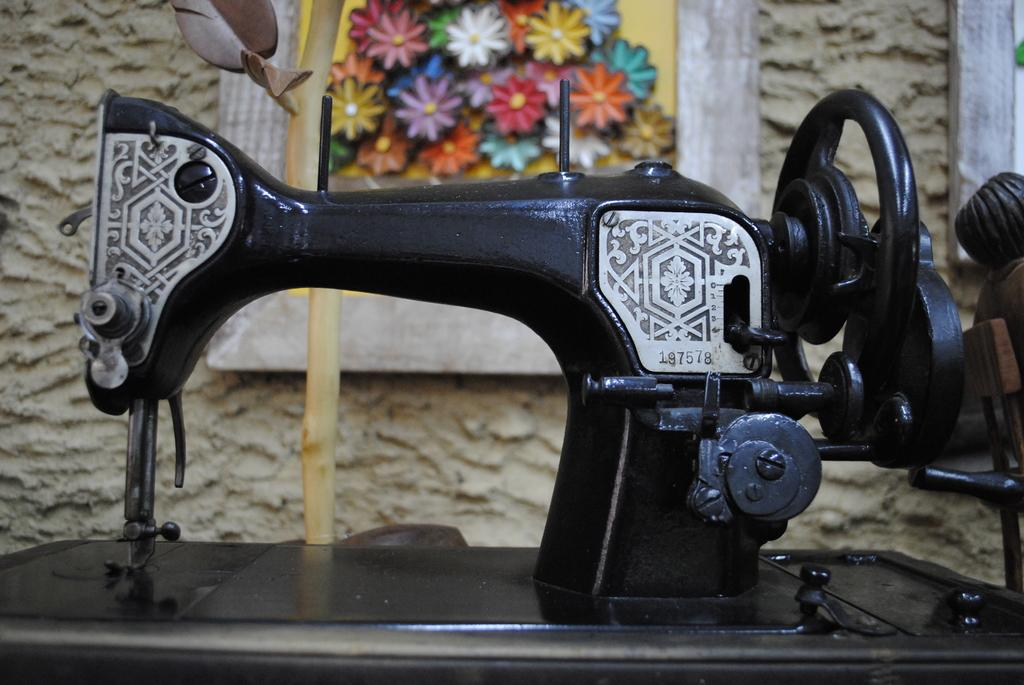What is the main object in the image? There is a sewing machine in the image. What can be seen in the background of the image? There is a wall in the background of the image. What is on the wall in the image? There is a frame on the wall. What type of copper material is used to make the sewing machine in the image? The sewing machine in the image is not made of copper; it is made of other materials. What type of marble is visible on the floor in the image? There is no marble visible on the floor in the image. 